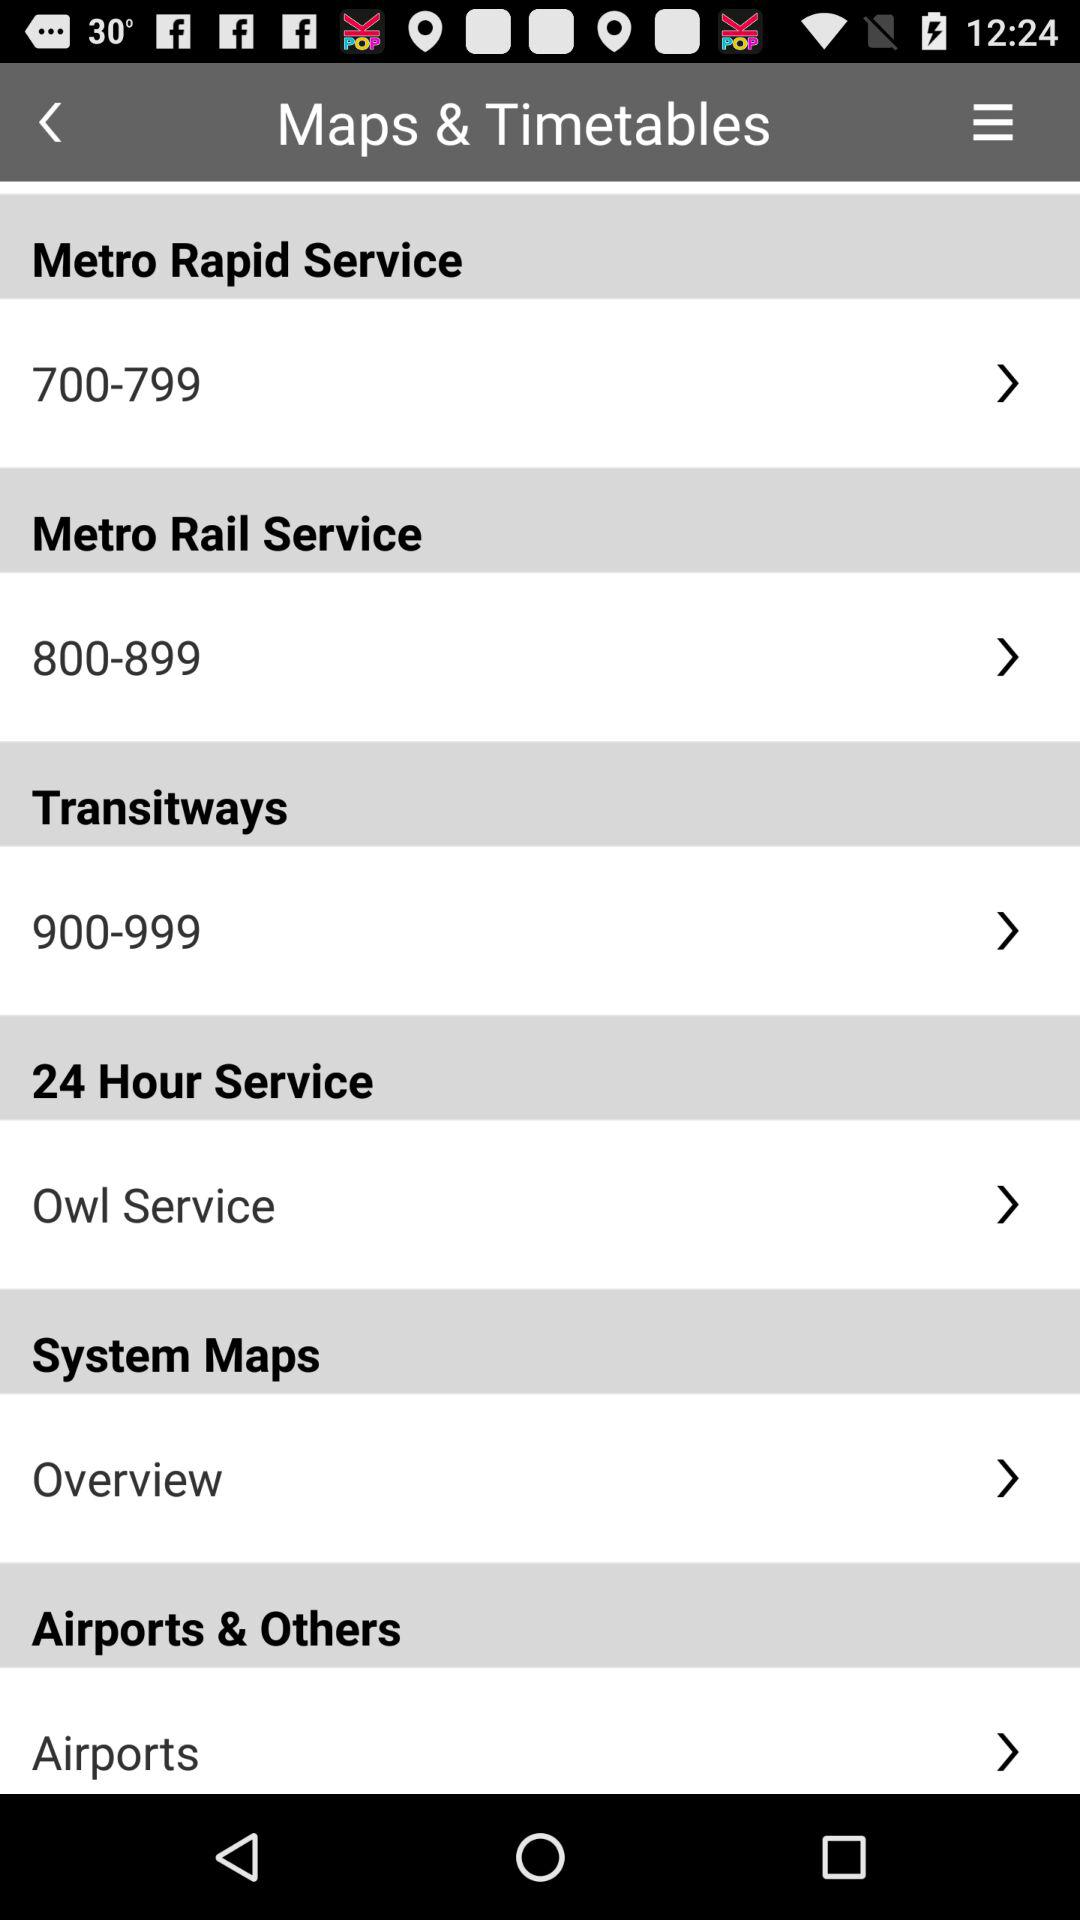Which range of numbers is used for the metro rapid service? The range of numbers is from 700 to 799. 